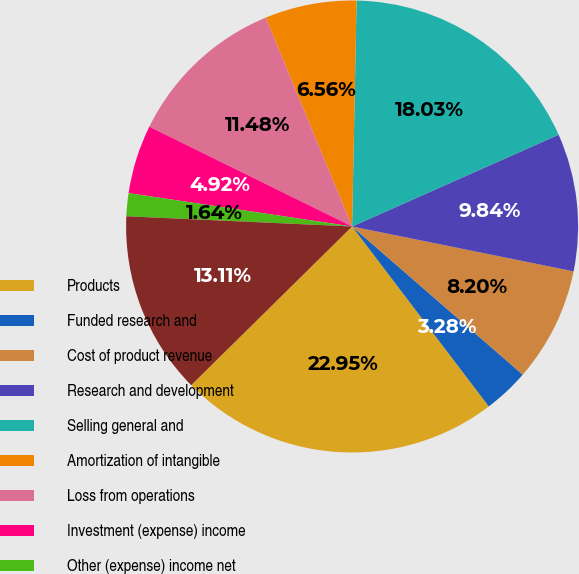<chart> <loc_0><loc_0><loc_500><loc_500><pie_chart><fcel>Products<fcel>Funded research and<fcel>Cost of product revenue<fcel>Research and development<fcel>Selling general and<fcel>Amortization of intangible<fcel>Loss from operations<fcel>Investment (expense) income<fcel>Other (expense) income net<fcel>Loss before provision for<nl><fcel>22.95%<fcel>3.28%<fcel>8.2%<fcel>9.84%<fcel>18.03%<fcel>6.56%<fcel>11.48%<fcel>4.92%<fcel>1.64%<fcel>13.11%<nl></chart> 